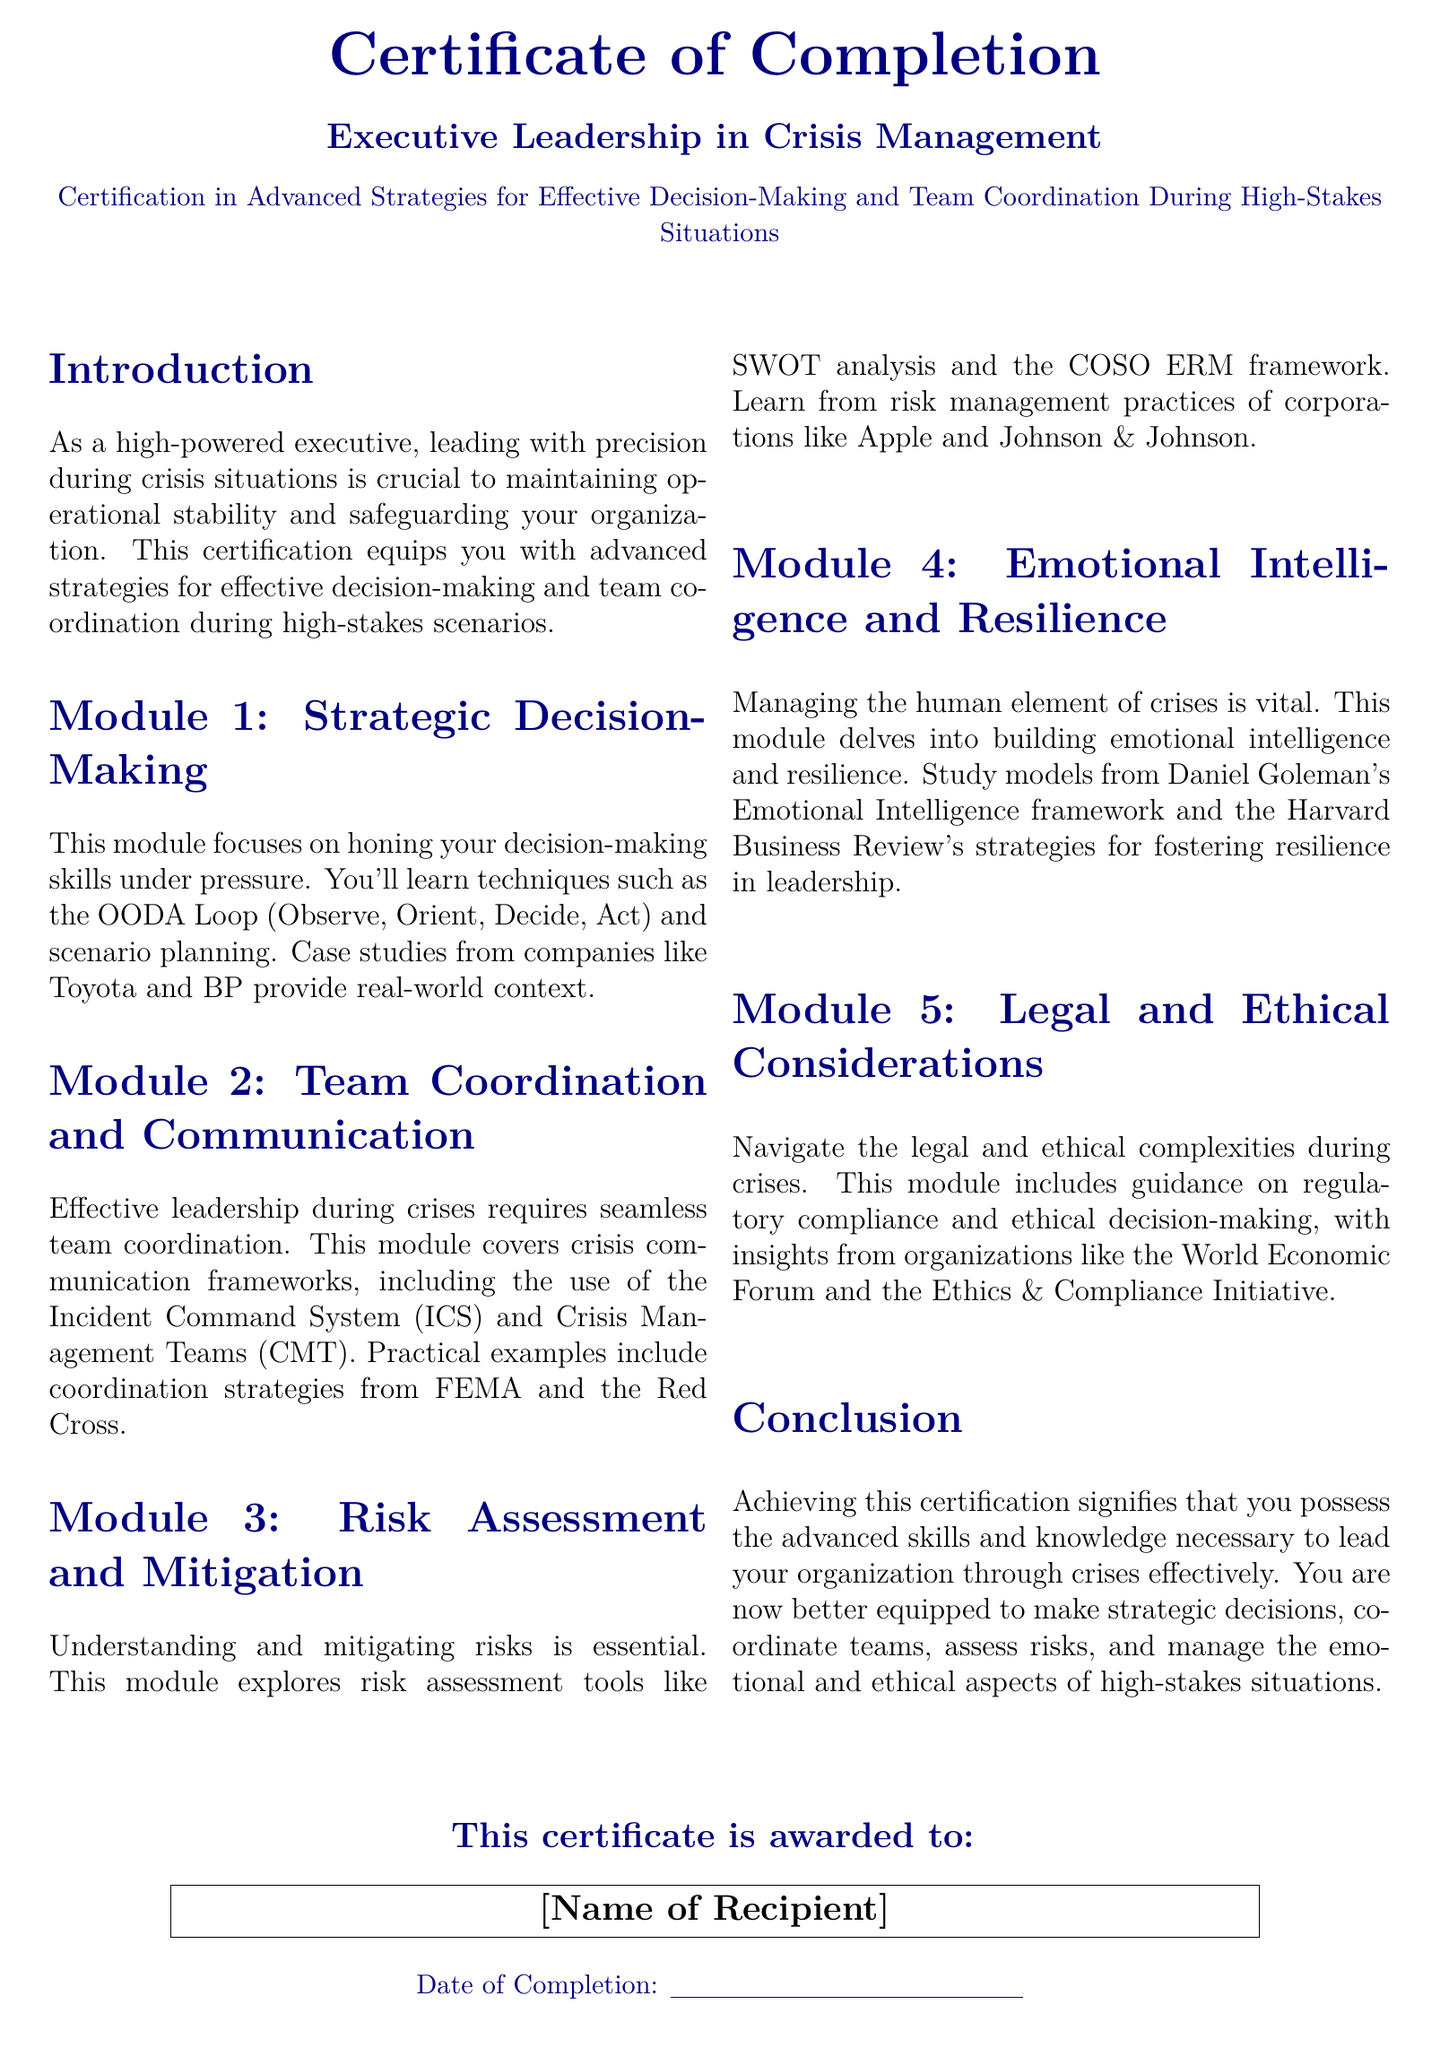What is the title of the certificate? The title of the certificate is prominently displayed in the document header.
Answer: Executive Leadership in Crisis Management What is the focus of Module 1? Each module covers specific themes related to the certification. Module 1 deals with decision-making under pressure.
Answer: Strategic Decision-Making Which framework is introduced in Module 2? Module 2 centers on team coordination in crisis situations. The framework mentioned is integral to this module.
Answer: Incident Command System Who are the case study examples in Module 1? Case studies from well-known companies provide real-world context to the learning material.
Answer: Toyota and BP What is emphasized in Module 4? Module 4 addresses a key aspect of leadership during crises, focusing on a particular capability.
Answer: Emotional Intelligence and Resilience What organizations are referenced for risk management practices? The document includes examples of reputable corporations in the risk assessment module.
Answer: Apple and Johnson & Johnson What ethics resource is mentioned in relation to legal considerations? The module on legal and ethical considerations draws insights from a well-known global organization.
Answer: World Economic Forum What is the document's completion indicator? The certificate features a specific statement to signify the completion of the certification program.
Answer: Date of Completion What does achieving this certification signify? The conclusion provides a summary of the knowledge and skills gained through the course.
Answer: Advanced skills and knowledge 